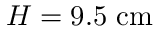<formula> <loc_0><loc_0><loc_500><loc_500>H = 9 . 5 c m</formula> 